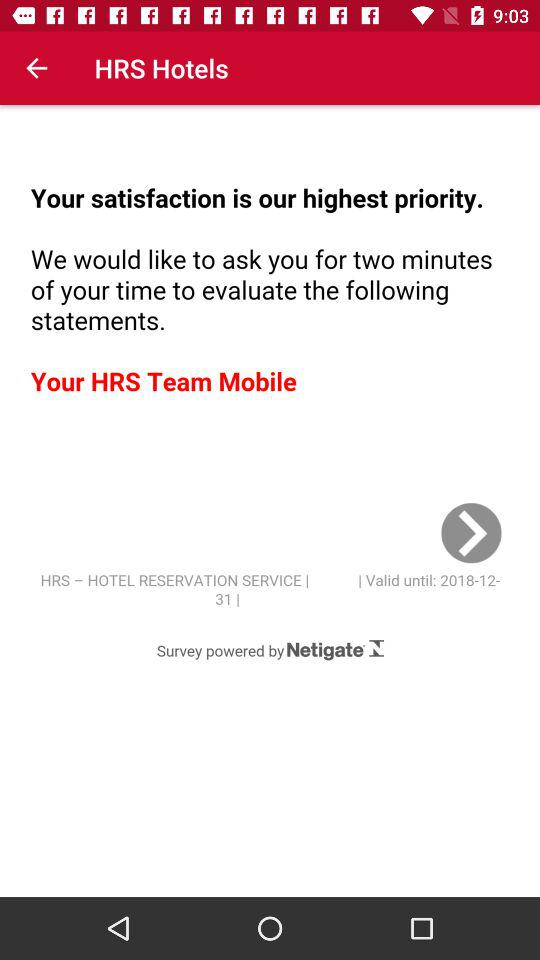What is the full form of HRS? The full form of HRS is Hotel Reservation Service. 